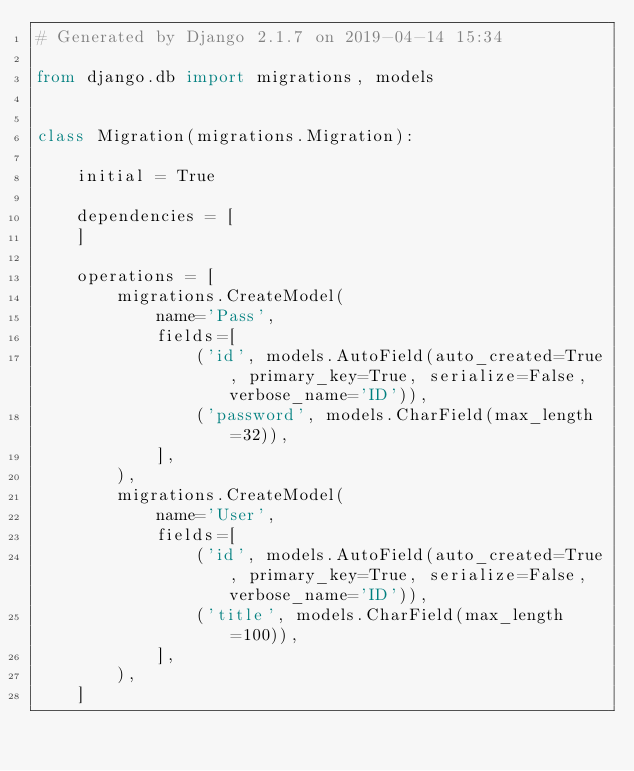Convert code to text. <code><loc_0><loc_0><loc_500><loc_500><_Python_># Generated by Django 2.1.7 on 2019-04-14 15:34

from django.db import migrations, models


class Migration(migrations.Migration):

    initial = True

    dependencies = [
    ]

    operations = [
        migrations.CreateModel(
            name='Pass',
            fields=[
                ('id', models.AutoField(auto_created=True, primary_key=True, serialize=False, verbose_name='ID')),
                ('password', models.CharField(max_length=32)),
            ],
        ),
        migrations.CreateModel(
            name='User',
            fields=[
                ('id', models.AutoField(auto_created=True, primary_key=True, serialize=False, verbose_name='ID')),
                ('title', models.CharField(max_length=100)),
            ],
        ),
    ]
</code> 